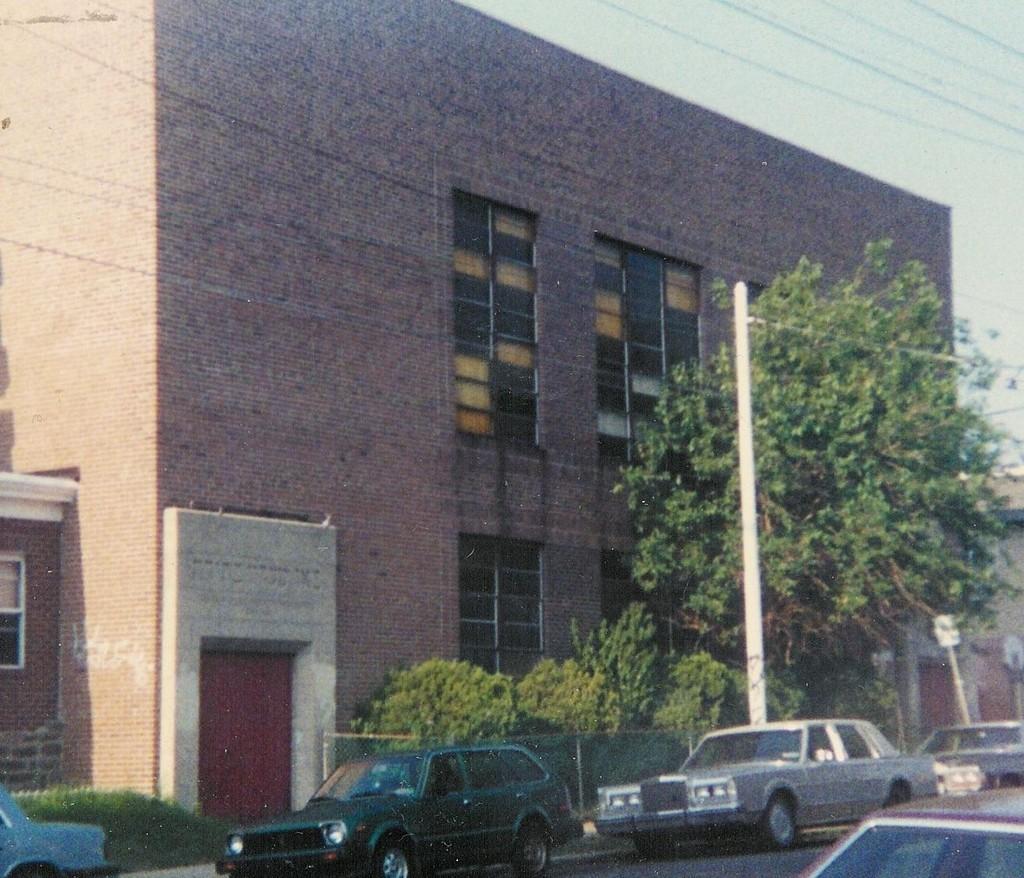In one or two sentences, can you explain what this image depicts? In the foreground I can see fleets of cars, trees, fence and a building on the road. On the top right I can see the sky. This image is taken during a day. 